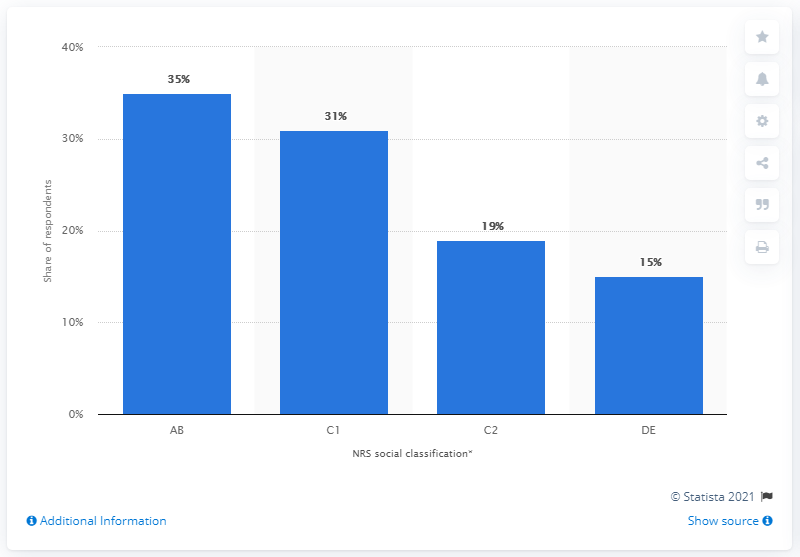Draw attention to some important aspects in this diagram. Debenhams customers belong to various classes, with the lowest being C1. According to a recent survey, 35% of Debenhams customers belonged to the demographic group of AB. 